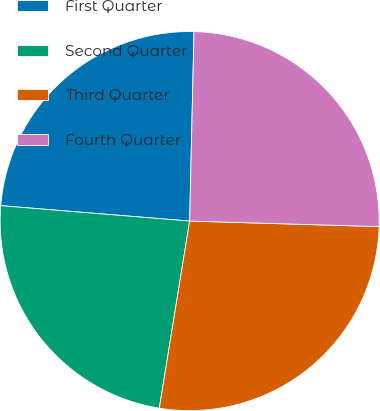Convert chart. <chart><loc_0><loc_0><loc_500><loc_500><pie_chart><fcel>First Quarter<fcel>Second Quarter<fcel>Third Quarter<fcel>Fourth Quarter<nl><fcel>24.07%<fcel>23.74%<fcel>27.09%<fcel>25.1%<nl></chart> 